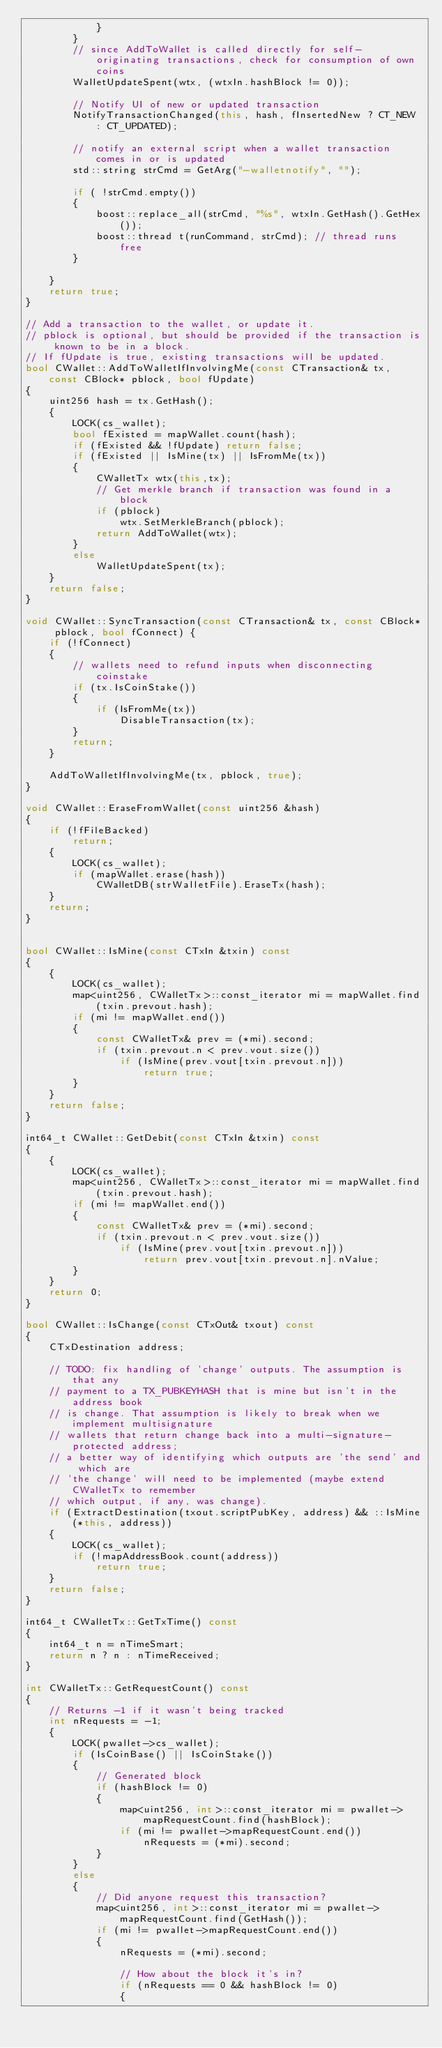Convert code to text. <code><loc_0><loc_0><loc_500><loc_500><_C++_>            }
        }
        // since AddToWallet is called directly for self-originating transactions, check for consumption of own coins
        WalletUpdateSpent(wtx, (wtxIn.hashBlock != 0));

        // Notify UI of new or updated transaction
        NotifyTransactionChanged(this, hash, fInsertedNew ? CT_NEW : CT_UPDATED);

        // notify an external script when a wallet transaction comes in or is updated
        std::string strCmd = GetArg("-walletnotify", "");

        if ( !strCmd.empty())
        {
            boost::replace_all(strCmd, "%s", wtxIn.GetHash().GetHex());
            boost::thread t(runCommand, strCmd); // thread runs free
        }

    }
    return true;
}

// Add a transaction to the wallet, or update it.
// pblock is optional, but should be provided if the transaction is known to be in a block.
// If fUpdate is true, existing transactions will be updated.
bool CWallet::AddToWalletIfInvolvingMe(const CTransaction& tx, const CBlock* pblock, bool fUpdate)
{
    uint256 hash = tx.GetHash();
    {
        LOCK(cs_wallet);
        bool fExisted = mapWallet.count(hash);
        if (fExisted && !fUpdate) return false;
        if (fExisted || IsMine(tx) || IsFromMe(tx))
        {
            CWalletTx wtx(this,tx);
            // Get merkle branch if transaction was found in a block
            if (pblock)
                wtx.SetMerkleBranch(pblock);
            return AddToWallet(wtx);
        }
        else
            WalletUpdateSpent(tx);
    }
    return false;
}

void CWallet::SyncTransaction(const CTransaction& tx, const CBlock* pblock, bool fConnect) {
    if (!fConnect)
    {
        // wallets need to refund inputs when disconnecting coinstake
        if (tx.IsCoinStake())
        {
            if (IsFromMe(tx))
                DisableTransaction(tx);
        }
        return;
    }

    AddToWalletIfInvolvingMe(tx, pblock, true);
}

void CWallet::EraseFromWallet(const uint256 &hash)
{
    if (!fFileBacked)
        return;
    {
        LOCK(cs_wallet);
        if (mapWallet.erase(hash))
            CWalletDB(strWalletFile).EraseTx(hash);
    }
    return;
}


bool CWallet::IsMine(const CTxIn &txin) const
{
    {
        LOCK(cs_wallet);
        map<uint256, CWalletTx>::const_iterator mi = mapWallet.find(txin.prevout.hash);
        if (mi != mapWallet.end())
        {
            const CWalletTx& prev = (*mi).second;
            if (txin.prevout.n < prev.vout.size())
                if (IsMine(prev.vout[txin.prevout.n]))
                    return true;
        }
    }
    return false;
}

int64_t CWallet::GetDebit(const CTxIn &txin) const
{
    {
        LOCK(cs_wallet);
        map<uint256, CWalletTx>::const_iterator mi = mapWallet.find(txin.prevout.hash);
        if (mi != mapWallet.end())
        {
            const CWalletTx& prev = (*mi).second;
            if (txin.prevout.n < prev.vout.size())
                if (IsMine(prev.vout[txin.prevout.n]))
                    return prev.vout[txin.prevout.n].nValue;
        }
    }
    return 0;
}

bool CWallet::IsChange(const CTxOut& txout) const
{
    CTxDestination address;

    // TODO: fix handling of 'change' outputs. The assumption is that any
    // payment to a TX_PUBKEYHASH that is mine but isn't in the address book
    // is change. That assumption is likely to break when we implement multisignature
    // wallets that return change back into a multi-signature-protected address;
    // a better way of identifying which outputs are 'the send' and which are
    // 'the change' will need to be implemented (maybe extend CWalletTx to remember
    // which output, if any, was change).
    if (ExtractDestination(txout.scriptPubKey, address) && ::IsMine(*this, address))
    {
        LOCK(cs_wallet);
        if (!mapAddressBook.count(address))
            return true;
    }
    return false;
}

int64_t CWalletTx::GetTxTime() const
{
    int64_t n = nTimeSmart;
    return n ? n : nTimeReceived;
}

int CWalletTx::GetRequestCount() const
{
    // Returns -1 if it wasn't being tracked
    int nRequests = -1;
    {
        LOCK(pwallet->cs_wallet);
        if (IsCoinBase() || IsCoinStake())
        {
            // Generated block
            if (hashBlock != 0)
            {
                map<uint256, int>::const_iterator mi = pwallet->mapRequestCount.find(hashBlock);
                if (mi != pwallet->mapRequestCount.end())
                    nRequests = (*mi).second;
            }
        }
        else
        {
            // Did anyone request this transaction?
            map<uint256, int>::const_iterator mi = pwallet->mapRequestCount.find(GetHash());
            if (mi != pwallet->mapRequestCount.end())
            {
                nRequests = (*mi).second;

                // How about the block it's in?
                if (nRequests == 0 && hashBlock != 0)
                {</code> 